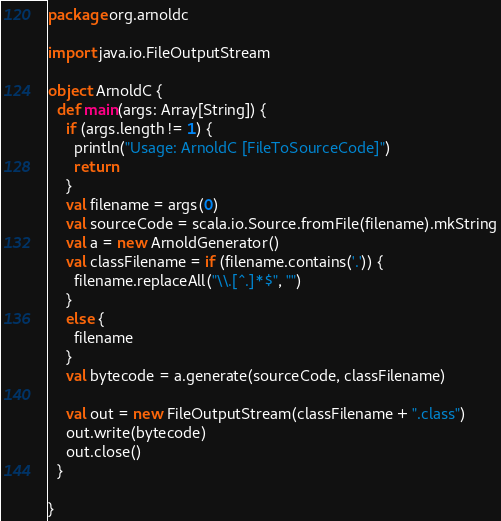<code> <loc_0><loc_0><loc_500><loc_500><_Scala_>package org.arnoldc

import java.io.FileOutputStream

object ArnoldC {
  def main(args: Array[String]) {
    if (args.length != 1) {
      println("Usage: ArnoldC [FileToSourceCode]")
      return
    }
    val filename = args(0)
    val sourceCode = scala.io.Source.fromFile(filename).mkString
    val a = new ArnoldGenerator()
    val classFilename = if (filename.contains('.')) {
      filename.replaceAll("\\.[^.]*$", "")
    }
    else {
      filename
    }
    val bytecode = a.generate(sourceCode, classFilename)

    val out = new FileOutputStream(classFilename + ".class")
    out.write(bytecode)
    out.close()
  }

}</code> 